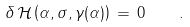Convert formula to latex. <formula><loc_0><loc_0><loc_500><loc_500>\delta \, \mathcal { H } \left ( \alpha , \sigma , \gamma ( \alpha ) \right ) \, = \, 0 \quad .</formula> 